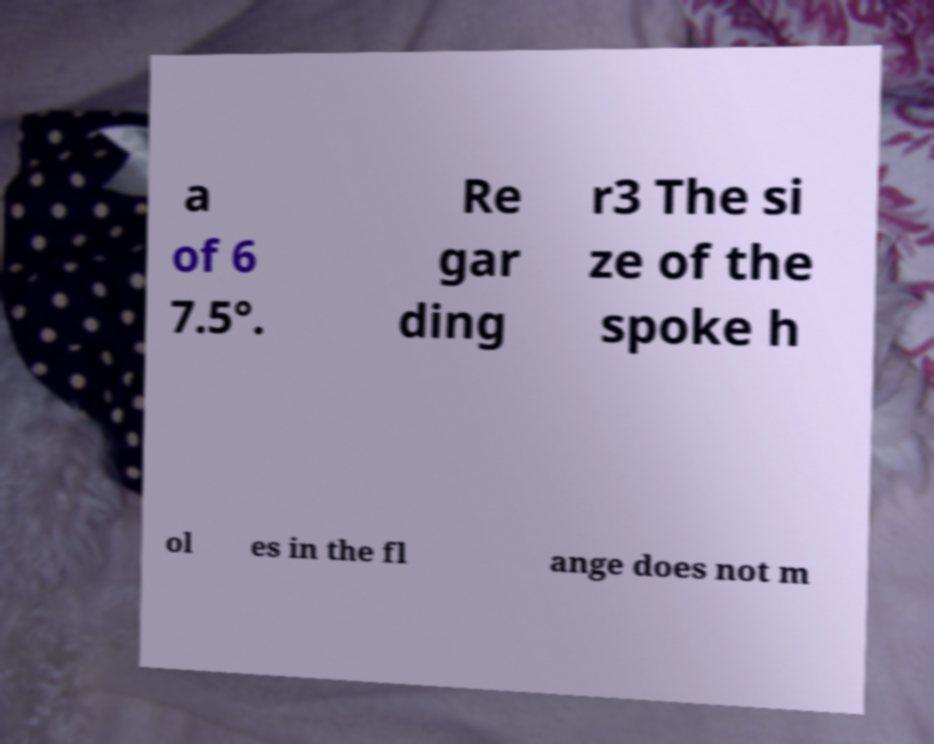Could you extract and type out the text from this image? a of 6 7.5°. Re gar ding r3 The si ze of the spoke h ol es in the fl ange does not m 